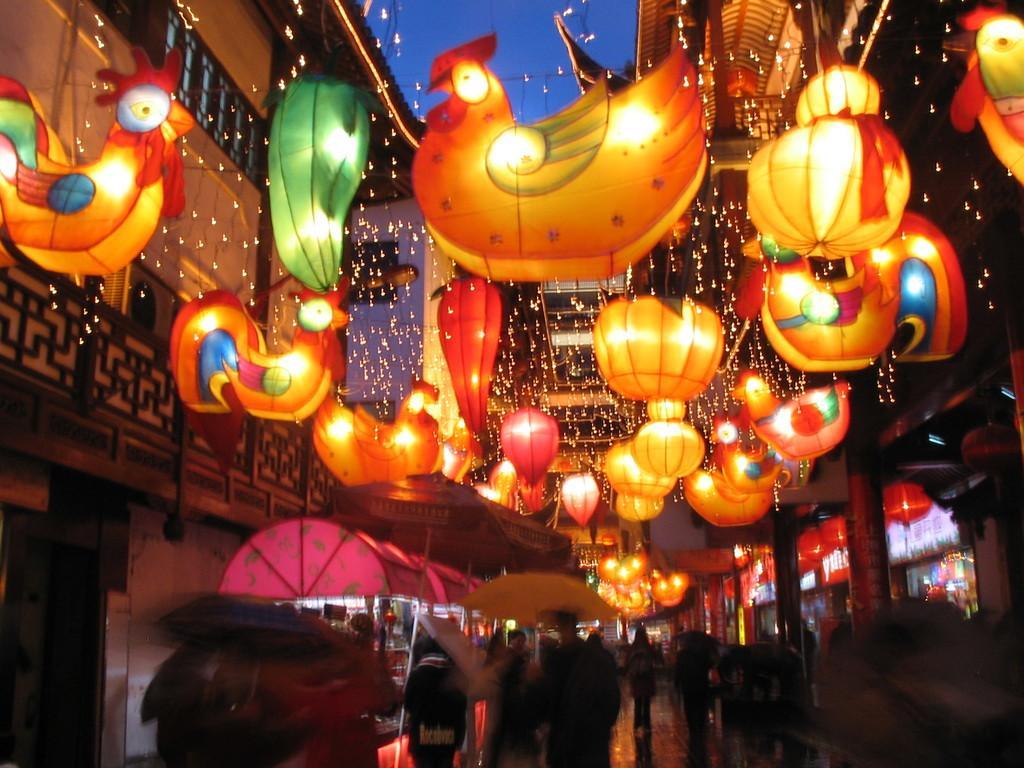In one or two sentences, can you explain what this image depicts? In this image I can see number of people on the bottom side and I can see few of them are holding umbrellas. On the top side of this image I can see number of lights, decorations and few buildings. I can also see the sky in the background. 